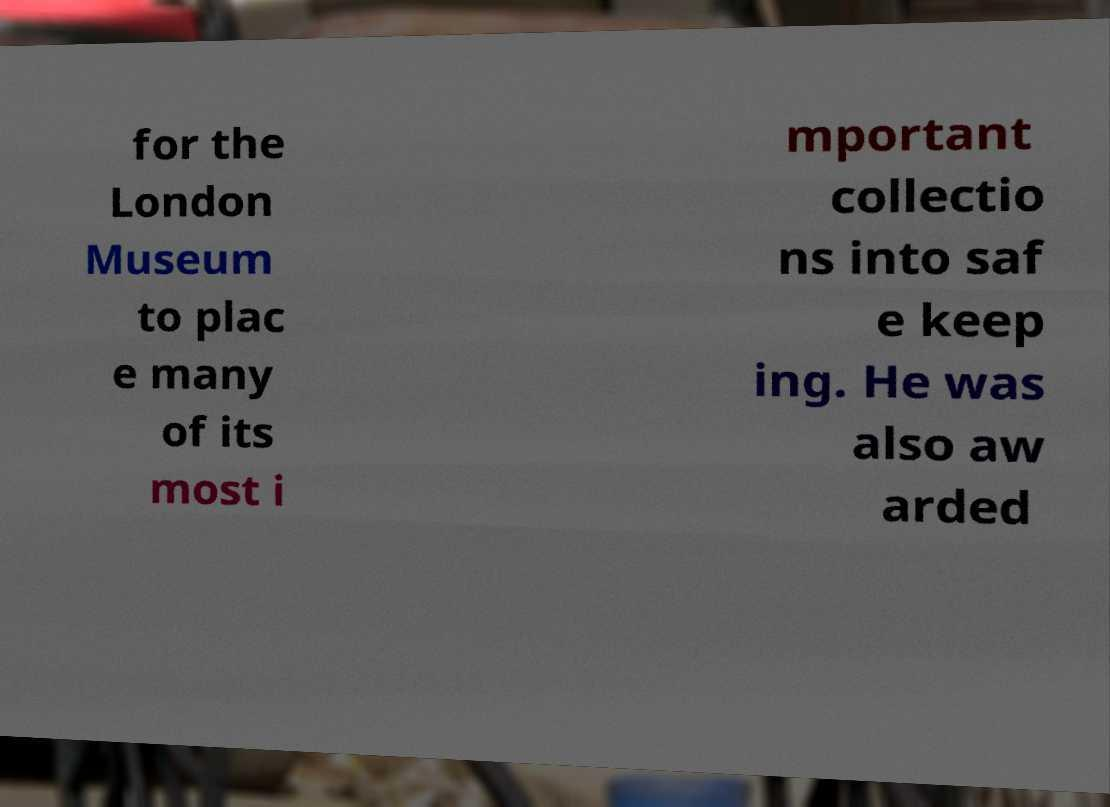Could you assist in decoding the text presented in this image and type it out clearly? for the London Museum to plac e many of its most i mportant collectio ns into saf e keep ing. He was also aw arded 